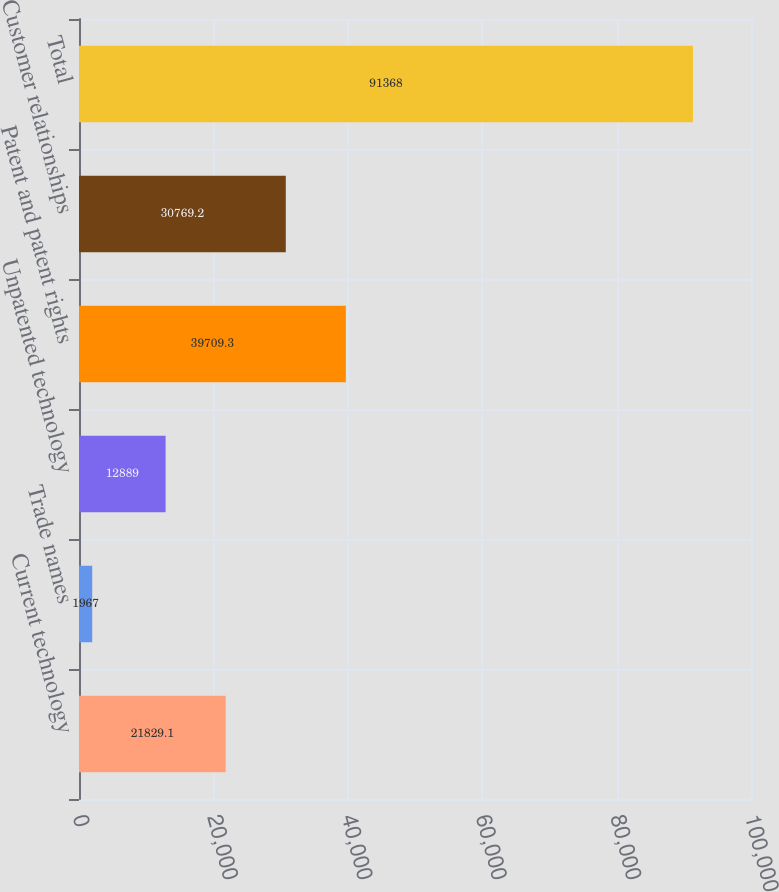Convert chart to OTSL. <chart><loc_0><loc_0><loc_500><loc_500><bar_chart><fcel>Current technology<fcel>Trade names<fcel>Unpatented technology<fcel>Patent and patent rights<fcel>Customer relationships<fcel>Total<nl><fcel>21829.1<fcel>1967<fcel>12889<fcel>39709.3<fcel>30769.2<fcel>91368<nl></chart> 